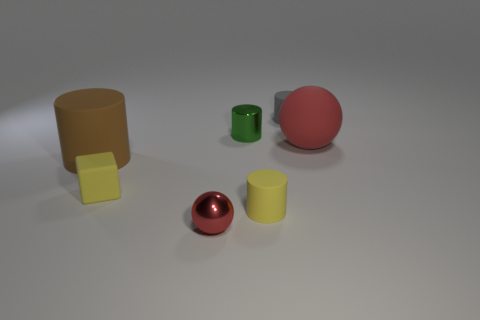There is a object that is the same color as the metallic sphere; what shape is it?
Your answer should be very brief. Sphere. What is the size of the brown cylinder that is the same material as the gray thing?
Provide a succinct answer. Large. Are there the same number of tiny yellow cubes that are to the right of the tiny green cylinder and tiny brown metal cylinders?
Keep it short and to the point. Yes. Do the tiny ball and the rubber ball have the same color?
Your answer should be very brief. Yes. There is a tiny object that is in front of the yellow rubber cylinder; is its shape the same as the big matte thing that is behind the brown thing?
Keep it short and to the point. Yes. There is a small green thing that is the same shape as the brown rubber thing; what material is it?
Give a very brief answer. Metal. The matte cylinder that is both right of the tiny yellow cube and in front of the green metal object is what color?
Make the answer very short. Yellow. Is there a small yellow object that is left of the rubber cylinder that is behind the red sphere behind the metallic ball?
Your answer should be very brief. Yes. How many things are either cyan metallic things or rubber objects?
Offer a terse response. 5. Is the tiny yellow block made of the same material as the small green thing left of the yellow cylinder?
Provide a succinct answer. No. 